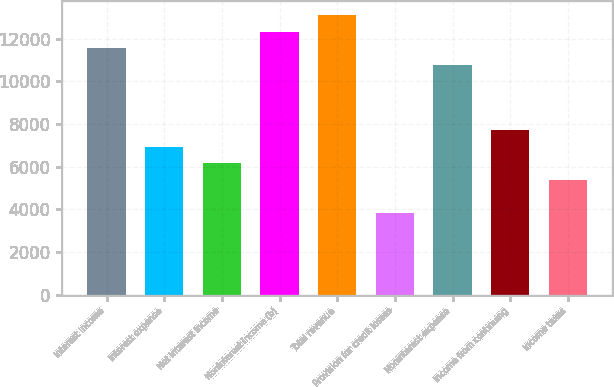<chart> <loc_0><loc_0><loc_500><loc_500><bar_chart><fcel>Interest income<fcel>Interest expense<fcel>Net interest income<fcel>Noninterest income (b)<fcel>Total revenue<fcel>Provision for credit losses<fcel>Noninterest expense<fcel>Income from continuing<fcel>Income taxes<nl><fcel>11557.3<fcel>6934.56<fcel>6164.1<fcel>12327.8<fcel>13098.2<fcel>3852.72<fcel>10786.9<fcel>7705.02<fcel>5393.64<nl></chart> 